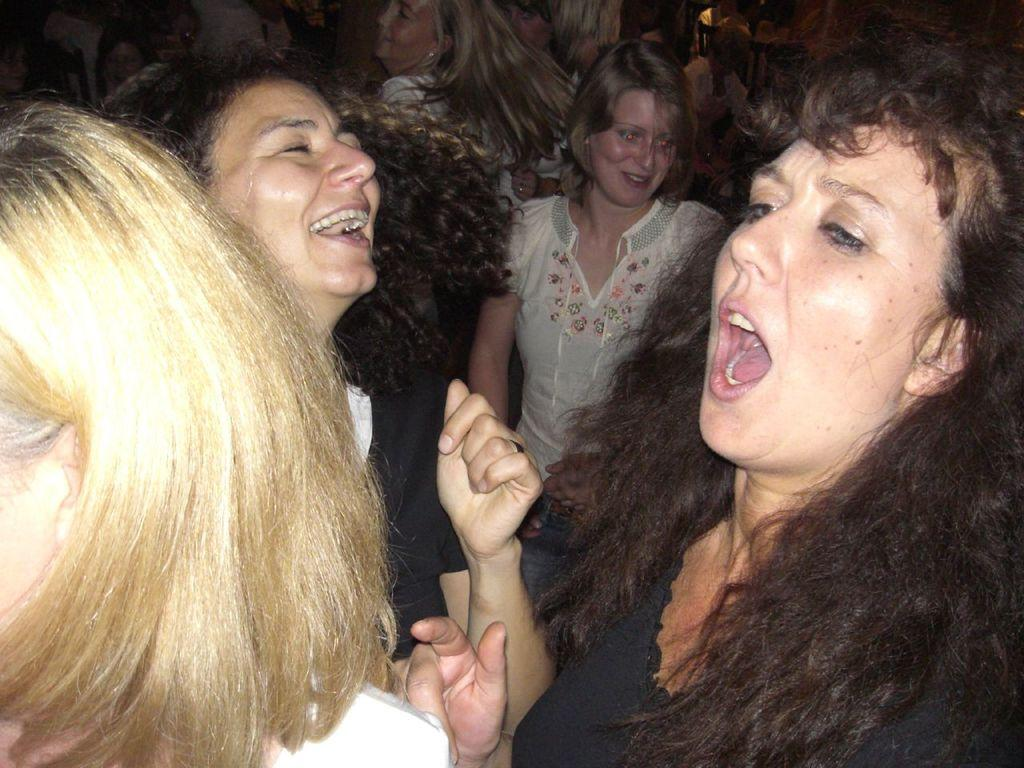What can be seen in the picture? There is a group of women in the picture. How are the women in the picture feeling? The women are smiling, which suggests they are happy or enjoying themselves. What type of bushes can be seen in the picture? There are no bushes present in the picture; it only features a group of women. What is the voice of the woman in the center of the picture? There is no information about the women's voices in the picture, as it only shows their facial expressions. 